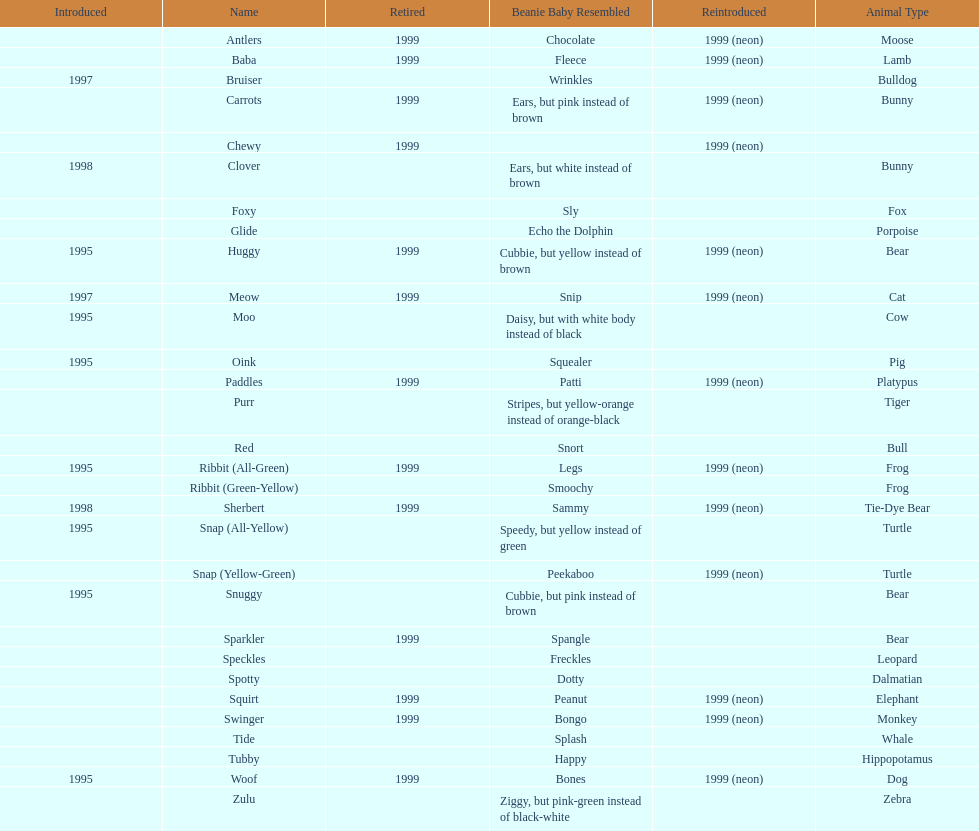What is the only dalmatian pillow pal called? Spotty. 